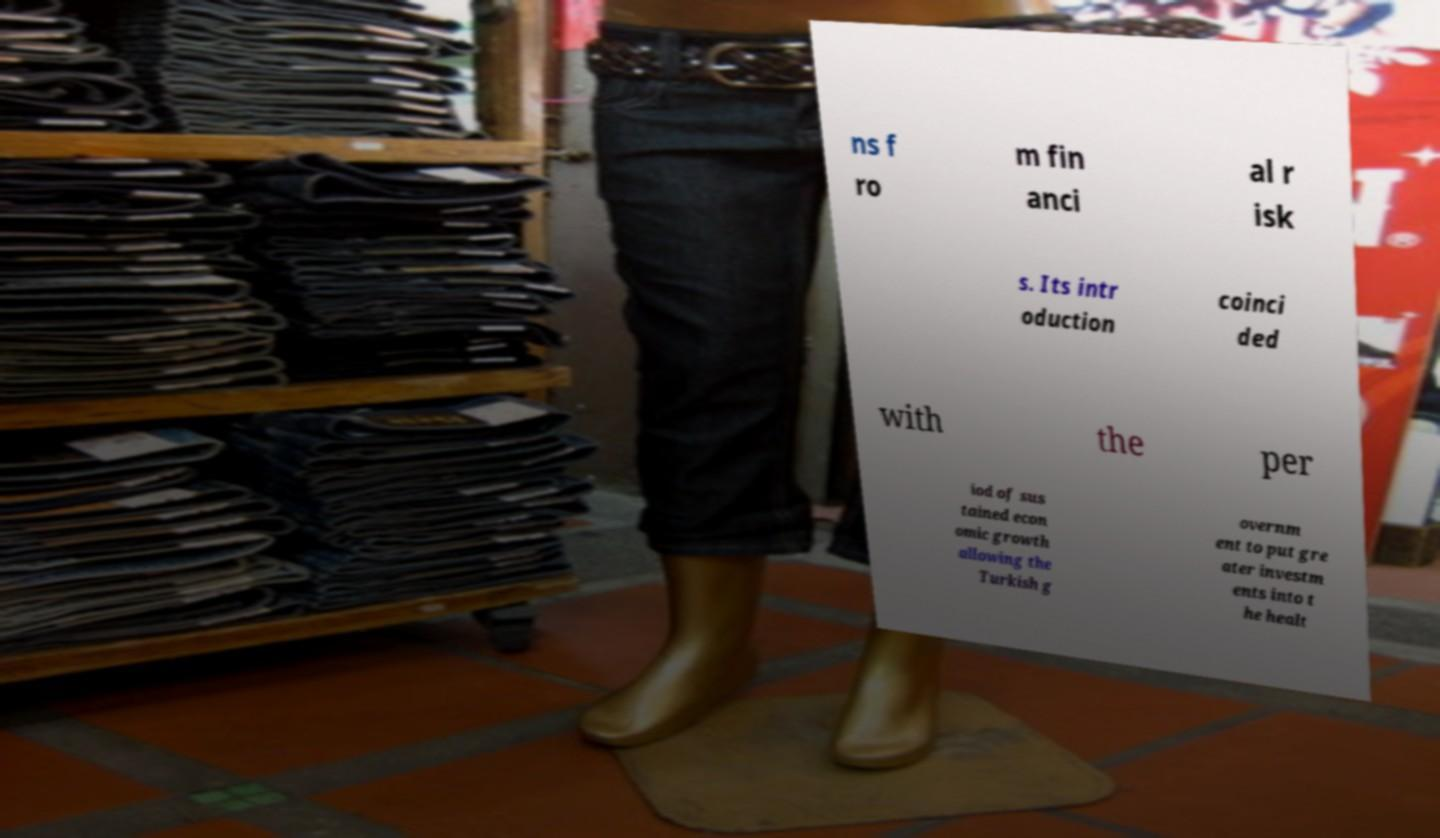What messages or text are displayed in this image? I need them in a readable, typed format. ns f ro m fin anci al r isk s. Its intr oduction coinci ded with the per iod of sus tained econ omic growth allowing the Turkish g overnm ent to put gre ater investm ents into t he healt 